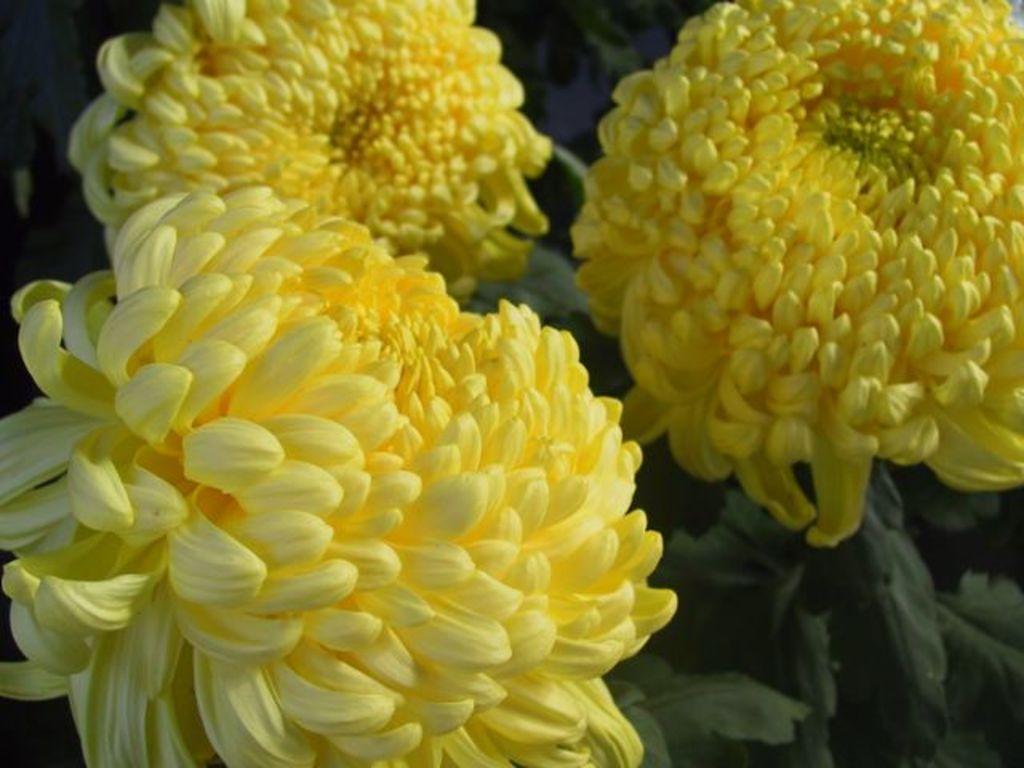Can you describe this image briefly? In the image we can see flowers, yellow in colour and these are the leaves. 